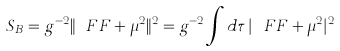Convert formula to latex. <formula><loc_0><loc_0><loc_500><loc_500>S _ { B } = g ^ { - 2 } \| \ F F + \mu ^ { 2 } \| ^ { 2 } = g ^ { - 2 } \int d \tau \, | \ F F + \mu ^ { 2 } | ^ { 2 }</formula> 